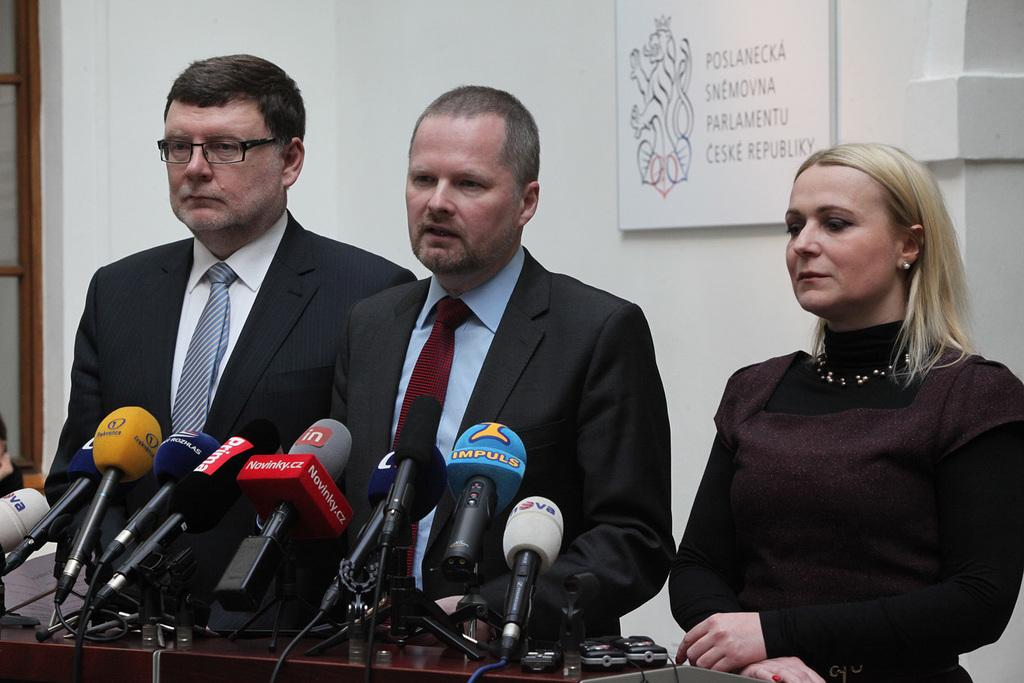How many people are in the image? There are a few people in the image. What is on the table in the image? There is a table with microphones in the image. What is on the wall in the image? There is a wall with a board in the image. What material can be seen on the left side of the image? There is wood visible on the left side of the image. What type of horse can be seen in the image? There is no horse present in the image. What is the connection between the people and the microphones in the image? The connection between the people and the microphones cannot be determined from the image alone, as it does not show any interaction or context. 